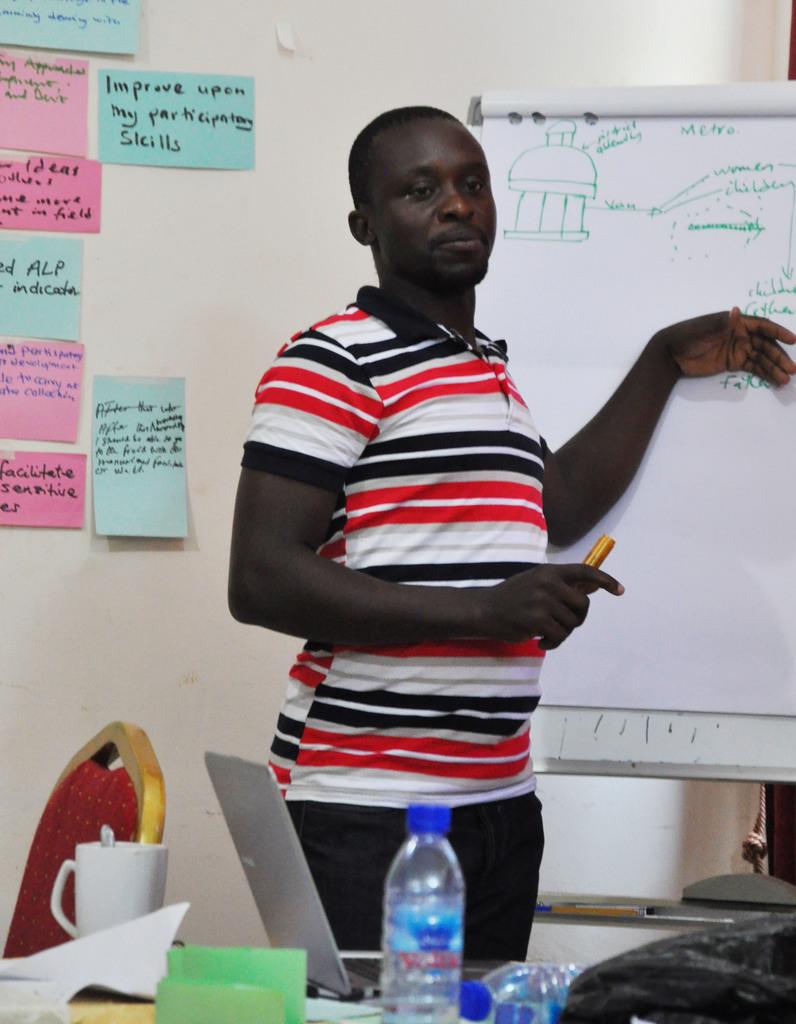What skills should you improve upon in this classroom?
Your answer should be compact. Participation. What word did he write on the top of the white paper?
Your response must be concise. Metro. 